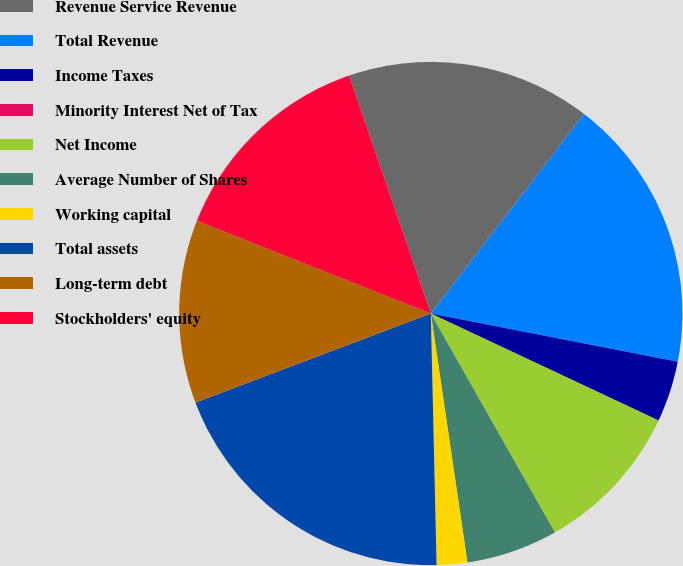Convert chart to OTSL. <chart><loc_0><loc_0><loc_500><loc_500><pie_chart><fcel>Revenue Service Revenue<fcel>Total Revenue<fcel>Income Taxes<fcel>Minority Interest Net of Tax<fcel>Net Income<fcel>Average Number of Shares<fcel>Working capital<fcel>Total assets<fcel>Long-term debt<fcel>Stockholders' equity<nl><fcel>15.68%<fcel>17.64%<fcel>3.92%<fcel>0.0%<fcel>9.8%<fcel>5.88%<fcel>1.96%<fcel>19.6%<fcel>11.76%<fcel>13.72%<nl></chart> 